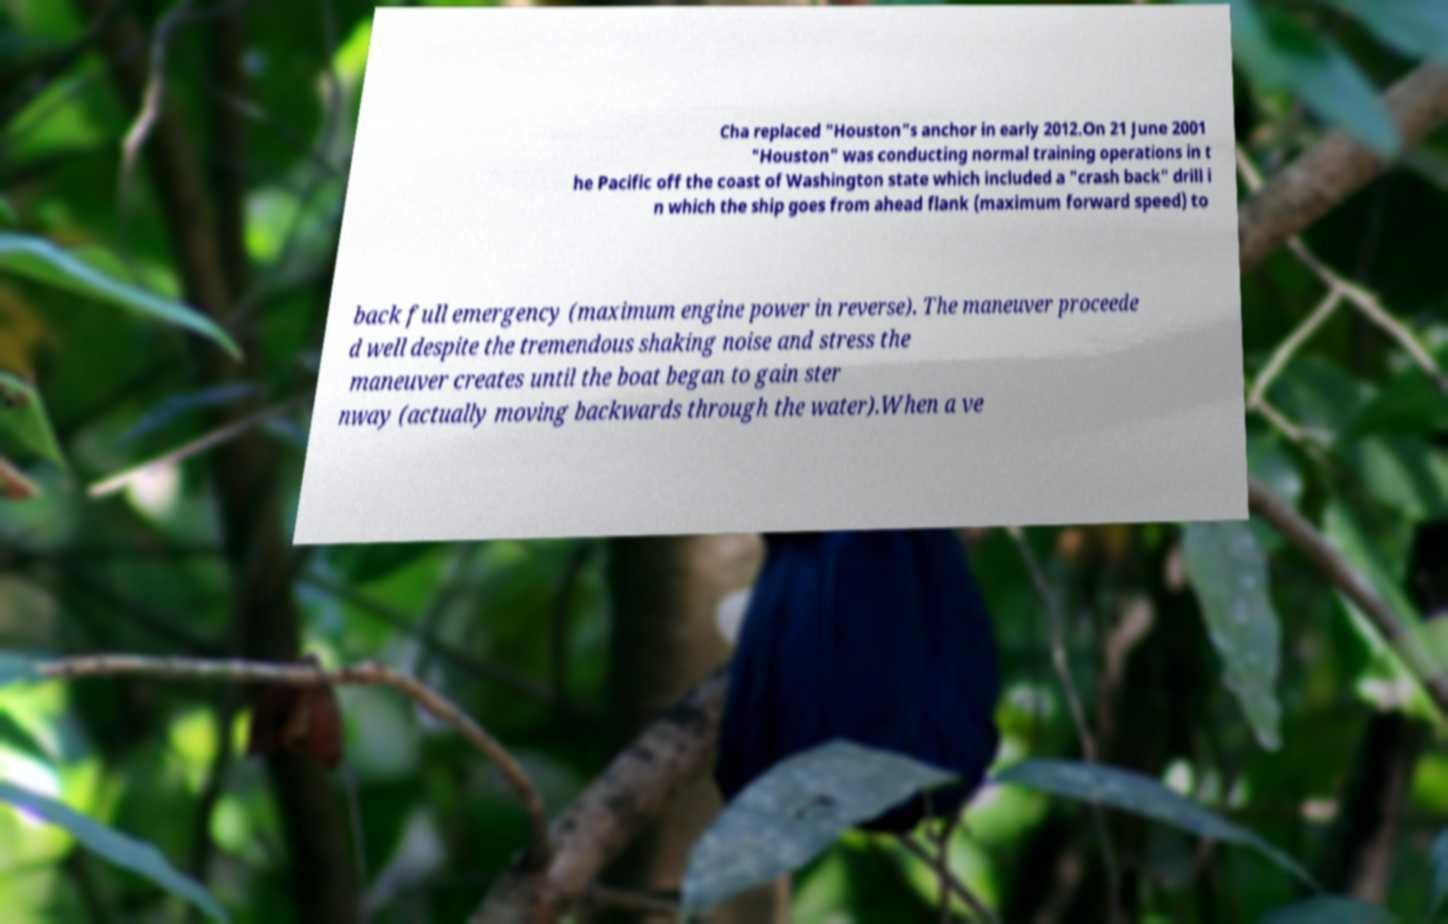Could you assist in decoding the text presented in this image and type it out clearly? Cha replaced "Houston"s anchor in early 2012.On 21 June 2001 "Houston" was conducting normal training operations in t he Pacific off the coast of Washington state which included a "crash back" drill i n which the ship goes from ahead flank (maximum forward speed) to back full emergency (maximum engine power in reverse). The maneuver proceede d well despite the tremendous shaking noise and stress the maneuver creates until the boat began to gain ster nway (actually moving backwards through the water).When a ve 